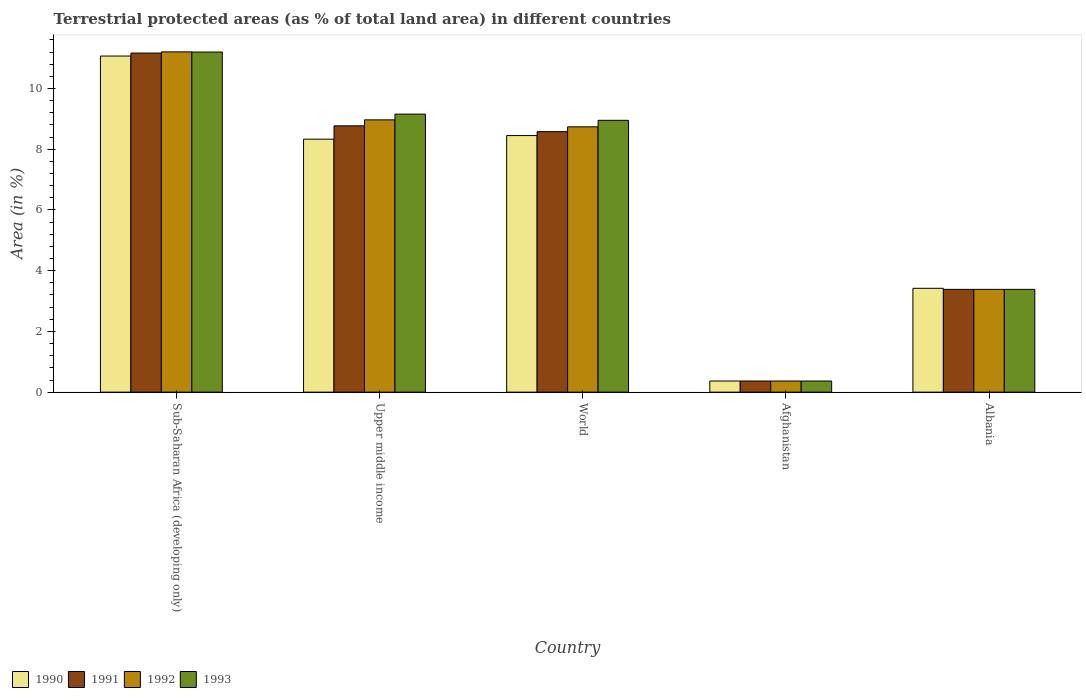How many groups of bars are there?
Your answer should be compact. 5. Are the number of bars per tick equal to the number of legend labels?
Give a very brief answer. Yes. Are the number of bars on each tick of the X-axis equal?
Your answer should be compact. Yes. How many bars are there on the 5th tick from the right?
Provide a short and direct response. 4. What is the label of the 5th group of bars from the left?
Keep it short and to the point. Albania. What is the percentage of terrestrial protected land in 1992 in Sub-Saharan Africa (developing only)?
Make the answer very short. 11.21. Across all countries, what is the maximum percentage of terrestrial protected land in 1990?
Your answer should be very brief. 11.07. Across all countries, what is the minimum percentage of terrestrial protected land in 1991?
Offer a terse response. 0.37. In which country was the percentage of terrestrial protected land in 1990 maximum?
Keep it short and to the point. Sub-Saharan Africa (developing only). In which country was the percentage of terrestrial protected land in 1991 minimum?
Provide a short and direct response. Afghanistan. What is the total percentage of terrestrial protected land in 1990 in the graph?
Provide a succinct answer. 31.64. What is the difference between the percentage of terrestrial protected land in 1991 in Afghanistan and that in World?
Ensure brevity in your answer.  -8.21. What is the difference between the percentage of terrestrial protected land in 1992 in Upper middle income and the percentage of terrestrial protected land in 1993 in Sub-Saharan Africa (developing only)?
Offer a terse response. -2.23. What is the average percentage of terrestrial protected land in 1991 per country?
Ensure brevity in your answer.  6.45. What is the difference between the percentage of terrestrial protected land of/in 1992 and percentage of terrestrial protected land of/in 1991 in Sub-Saharan Africa (developing only)?
Your response must be concise. 0.04. In how many countries, is the percentage of terrestrial protected land in 1993 greater than 5.6 %?
Give a very brief answer. 3. What is the ratio of the percentage of terrestrial protected land in 1993 in Afghanistan to that in Upper middle income?
Provide a short and direct response. 0.04. Is the percentage of terrestrial protected land in 1992 in Afghanistan less than that in Upper middle income?
Provide a succinct answer. Yes. What is the difference between the highest and the second highest percentage of terrestrial protected land in 1993?
Provide a short and direct response. -0.2. What is the difference between the highest and the lowest percentage of terrestrial protected land in 1991?
Make the answer very short. 10.8. Is the sum of the percentage of terrestrial protected land in 1990 in Afghanistan and World greater than the maximum percentage of terrestrial protected land in 1993 across all countries?
Ensure brevity in your answer.  No. What does the 2nd bar from the left in Upper middle income represents?
Provide a succinct answer. 1991. How many bars are there?
Make the answer very short. 20. Are all the bars in the graph horizontal?
Ensure brevity in your answer.  No. What is the difference between two consecutive major ticks on the Y-axis?
Your response must be concise. 2. What is the title of the graph?
Your response must be concise. Terrestrial protected areas (as % of total land area) in different countries. Does "1992" appear as one of the legend labels in the graph?
Give a very brief answer. Yes. What is the label or title of the Y-axis?
Keep it short and to the point. Area (in %). What is the Area (in %) in 1990 in Sub-Saharan Africa (developing only)?
Give a very brief answer. 11.07. What is the Area (in %) in 1991 in Sub-Saharan Africa (developing only)?
Offer a very short reply. 11.17. What is the Area (in %) in 1992 in Sub-Saharan Africa (developing only)?
Provide a succinct answer. 11.21. What is the Area (in %) of 1993 in Sub-Saharan Africa (developing only)?
Give a very brief answer. 11.2. What is the Area (in %) in 1990 in Upper middle income?
Make the answer very short. 8.33. What is the Area (in %) of 1991 in Upper middle income?
Offer a terse response. 8.77. What is the Area (in %) in 1992 in Upper middle income?
Provide a short and direct response. 8.97. What is the Area (in %) of 1993 in Upper middle income?
Offer a very short reply. 9.16. What is the Area (in %) of 1990 in World?
Offer a terse response. 8.45. What is the Area (in %) of 1991 in World?
Give a very brief answer. 8.58. What is the Area (in %) of 1992 in World?
Ensure brevity in your answer.  8.74. What is the Area (in %) of 1993 in World?
Your answer should be very brief. 8.95. What is the Area (in %) of 1990 in Afghanistan?
Give a very brief answer. 0.37. What is the Area (in %) of 1991 in Afghanistan?
Keep it short and to the point. 0.37. What is the Area (in %) of 1992 in Afghanistan?
Offer a terse response. 0.37. What is the Area (in %) in 1993 in Afghanistan?
Keep it short and to the point. 0.37. What is the Area (in %) of 1990 in Albania?
Make the answer very short. 3.42. What is the Area (in %) of 1991 in Albania?
Make the answer very short. 3.38. What is the Area (in %) in 1992 in Albania?
Keep it short and to the point. 3.38. What is the Area (in %) in 1993 in Albania?
Keep it short and to the point. 3.38. Across all countries, what is the maximum Area (in %) of 1990?
Your response must be concise. 11.07. Across all countries, what is the maximum Area (in %) in 1991?
Provide a succinct answer. 11.17. Across all countries, what is the maximum Area (in %) in 1992?
Keep it short and to the point. 11.21. Across all countries, what is the maximum Area (in %) of 1993?
Provide a short and direct response. 11.2. Across all countries, what is the minimum Area (in %) of 1990?
Provide a short and direct response. 0.37. Across all countries, what is the minimum Area (in %) of 1991?
Offer a terse response. 0.37. Across all countries, what is the minimum Area (in %) in 1992?
Your answer should be compact. 0.37. Across all countries, what is the minimum Area (in %) in 1993?
Keep it short and to the point. 0.37. What is the total Area (in %) of 1990 in the graph?
Provide a succinct answer. 31.64. What is the total Area (in %) in 1991 in the graph?
Provide a short and direct response. 32.27. What is the total Area (in %) in 1992 in the graph?
Keep it short and to the point. 32.67. What is the total Area (in %) of 1993 in the graph?
Ensure brevity in your answer.  33.06. What is the difference between the Area (in %) in 1990 in Sub-Saharan Africa (developing only) and that in Upper middle income?
Keep it short and to the point. 2.74. What is the difference between the Area (in %) of 1991 in Sub-Saharan Africa (developing only) and that in Upper middle income?
Keep it short and to the point. 2.4. What is the difference between the Area (in %) in 1992 in Sub-Saharan Africa (developing only) and that in Upper middle income?
Provide a short and direct response. 2.24. What is the difference between the Area (in %) in 1993 in Sub-Saharan Africa (developing only) and that in Upper middle income?
Your answer should be very brief. 2.04. What is the difference between the Area (in %) in 1990 in Sub-Saharan Africa (developing only) and that in World?
Provide a succinct answer. 2.62. What is the difference between the Area (in %) of 1991 in Sub-Saharan Africa (developing only) and that in World?
Make the answer very short. 2.59. What is the difference between the Area (in %) of 1992 in Sub-Saharan Africa (developing only) and that in World?
Offer a very short reply. 2.47. What is the difference between the Area (in %) in 1993 in Sub-Saharan Africa (developing only) and that in World?
Your response must be concise. 2.25. What is the difference between the Area (in %) in 1990 in Sub-Saharan Africa (developing only) and that in Afghanistan?
Your answer should be very brief. 10.7. What is the difference between the Area (in %) of 1991 in Sub-Saharan Africa (developing only) and that in Afghanistan?
Make the answer very short. 10.8. What is the difference between the Area (in %) of 1992 in Sub-Saharan Africa (developing only) and that in Afghanistan?
Offer a terse response. 10.84. What is the difference between the Area (in %) of 1993 in Sub-Saharan Africa (developing only) and that in Afghanistan?
Offer a very short reply. 10.83. What is the difference between the Area (in %) in 1990 in Sub-Saharan Africa (developing only) and that in Albania?
Offer a terse response. 7.65. What is the difference between the Area (in %) of 1991 in Sub-Saharan Africa (developing only) and that in Albania?
Keep it short and to the point. 7.78. What is the difference between the Area (in %) of 1992 in Sub-Saharan Africa (developing only) and that in Albania?
Provide a short and direct response. 7.82. What is the difference between the Area (in %) of 1993 in Sub-Saharan Africa (developing only) and that in Albania?
Give a very brief answer. 7.82. What is the difference between the Area (in %) of 1990 in Upper middle income and that in World?
Ensure brevity in your answer.  -0.12. What is the difference between the Area (in %) in 1991 in Upper middle income and that in World?
Your response must be concise. 0.19. What is the difference between the Area (in %) of 1992 in Upper middle income and that in World?
Give a very brief answer. 0.23. What is the difference between the Area (in %) of 1993 in Upper middle income and that in World?
Your answer should be very brief. 0.2. What is the difference between the Area (in %) of 1990 in Upper middle income and that in Afghanistan?
Make the answer very short. 7.97. What is the difference between the Area (in %) of 1991 in Upper middle income and that in Afghanistan?
Make the answer very short. 8.4. What is the difference between the Area (in %) in 1992 in Upper middle income and that in Afghanistan?
Provide a short and direct response. 8.6. What is the difference between the Area (in %) of 1993 in Upper middle income and that in Afghanistan?
Your answer should be very brief. 8.79. What is the difference between the Area (in %) of 1990 in Upper middle income and that in Albania?
Provide a succinct answer. 4.91. What is the difference between the Area (in %) of 1991 in Upper middle income and that in Albania?
Your response must be concise. 5.39. What is the difference between the Area (in %) of 1992 in Upper middle income and that in Albania?
Offer a terse response. 5.58. What is the difference between the Area (in %) of 1993 in Upper middle income and that in Albania?
Your answer should be very brief. 5.77. What is the difference between the Area (in %) of 1990 in World and that in Afghanistan?
Provide a succinct answer. 8.08. What is the difference between the Area (in %) of 1991 in World and that in Afghanistan?
Your response must be concise. 8.21. What is the difference between the Area (in %) in 1992 in World and that in Afghanistan?
Your response must be concise. 8.37. What is the difference between the Area (in %) in 1993 in World and that in Afghanistan?
Your answer should be very brief. 8.59. What is the difference between the Area (in %) of 1990 in World and that in Albania?
Provide a succinct answer. 5.03. What is the difference between the Area (in %) in 1991 in World and that in Albania?
Keep it short and to the point. 5.2. What is the difference between the Area (in %) of 1992 in World and that in Albania?
Provide a succinct answer. 5.35. What is the difference between the Area (in %) of 1993 in World and that in Albania?
Provide a short and direct response. 5.57. What is the difference between the Area (in %) in 1990 in Afghanistan and that in Albania?
Your response must be concise. -3.05. What is the difference between the Area (in %) in 1991 in Afghanistan and that in Albania?
Ensure brevity in your answer.  -3.02. What is the difference between the Area (in %) in 1992 in Afghanistan and that in Albania?
Keep it short and to the point. -3.02. What is the difference between the Area (in %) of 1993 in Afghanistan and that in Albania?
Offer a terse response. -3.02. What is the difference between the Area (in %) in 1990 in Sub-Saharan Africa (developing only) and the Area (in %) in 1991 in Upper middle income?
Ensure brevity in your answer.  2.3. What is the difference between the Area (in %) in 1990 in Sub-Saharan Africa (developing only) and the Area (in %) in 1992 in Upper middle income?
Offer a terse response. 2.1. What is the difference between the Area (in %) in 1990 in Sub-Saharan Africa (developing only) and the Area (in %) in 1993 in Upper middle income?
Offer a very short reply. 1.91. What is the difference between the Area (in %) in 1991 in Sub-Saharan Africa (developing only) and the Area (in %) in 1992 in Upper middle income?
Make the answer very short. 2.2. What is the difference between the Area (in %) in 1991 in Sub-Saharan Africa (developing only) and the Area (in %) in 1993 in Upper middle income?
Your response must be concise. 2.01. What is the difference between the Area (in %) in 1992 in Sub-Saharan Africa (developing only) and the Area (in %) in 1993 in Upper middle income?
Provide a succinct answer. 2.05. What is the difference between the Area (in %) in 1990 in Sub-Saharan Africa (developing only) and the Area (in %) in 1991 in World?
Your answer should be compact. 2.49. What is the difference between the Area (in %) in 1990 in Sub-Saharan Africa (developing only) and the Area (in %) in 1992 in World?
Ensure brevity in your answer.  2.33. What is the difference between the Area (in %) in 1990 in Sub-Saharan Africa (developing only) and the Area (in %) in 1993 in World?
Ensure brevity in your answer.  2.12. What is the difference between the Area (in %) in 1991 in Sub-Saharan Africa (developing only) and the Area (in %) in 1992 in World?
Your answer should be compact. 2.43. What is the difference between the Area (in %) of 1991 in Sub-Saharan Africa (developing only) and the Area (in %) of 1993 in World?
Provide a succinct answer. 2.22. What is the difference between the Area (in %) of 1992 in Sub-Saharan Africa (developing only) and the Area (in %) of 1993 in World?
Your answer should be compact. 2.25. What is the difference between the Area (in %) of 1990 in Sub-Saharan Africa (developing only) and the Area (in %) of 1991 in Afghanistan?
Offer a terse response. 10.7. What is the difference between the Area (in %) of 1990 in Sub-Saharan Africa (developing only) and the Area (in %) of 1992 in Afghanistan?
Provide a short and direct response. 10.7. What is the difference between the Area (in %) of 1990 in Sub-Saharan Africa (developing only) and the Area (in %) of 1993 in Afghanistan?
Your answer should be very brief. 10.7. What is the difference between the Area (in %) in 1991 in Sub-Saharan Africa (developing only) and the Area (in %) in 1992 in Afghanistan?
Your response must be concise. 10.8. What is the difference between the Area (in %) of 1991 in Sub-Saharan Africa (developing only) and the Area (in %) of 1993 in Afghanistan?
Give a very brief answer. 10.8. What is the difference between the Area (in %) in 1992 in Sub-Saharan Africa (developing only) and the Area (in %) in 1993 in Afghanistan?
Ensure brevity in your answer.  10.84. What is the difference between the Area (in %) of 1990 in Sub-Saharan Africa (developing only) and the Area (in %) of 1991 in Albania?
Ensure brevity in your answer.  7.68. What is the difference between the Area (in %) in 1990 in Sub-Saharan Africa (developing only) and the Area (in %) in 1992 in Albania?
Provide a succinct answer. 7.68. What is the difference between the Area (in %) in 1990 in Sub-Saharan Africa (developing only) and the Area (in %) in 1993 in Albania?
Offer a terse response. 7.68. What is the difference between the Area (in %) in 1991 in Sub-Saharan Africa (developing only) and the Area (in %) in 1992 in Albania?
Give a very brief answer. 7.78. What is the difference between the Area (in %) of 1991 in Sub-Saharan Africa (developing only) and the Area (in %) of 1993 in Albania?
Make the answer very short. 7.78. What is the difference between the Area (in %) in 1992 in Sub-Saharan Africa (developing only) and the Area (in %) in 1993 in Albania?
Make the answer very short. 7.82. What is the difference between the Area (in %) of 1990 in Upper middle income and the Area (in %) of 1991 in World?
Provide a short and direct response. -0.25. What is the difference between the Area (in %) of 1990 in Upper middle income and the Area (in %) of 1992 in World?
Keep it short and to the point. -0.41. What is the difference between the Area (in %) in 1990 in Upper middle income and the Area (in %) in 1993 in World?
Ensure brevity in your answer.  -0.62. What is the difference between the Area (in %) of 1991 in Upper middle income and the Area (in %) of 1992 in World?
Provide a short and direct response. 0.03. What is the difference between the Area (in %) in 1991 in Upper middle income and the Area (in %) in 1993 in World?
Your response must be concise. -0.18. What is the difference between the Area (in %) in 1992 in Upper middle income and the Area (in %) in 1993 in World?
Ensure brevity in your answer.  0.02. What is the difference between the Area (in %) in 1990 in Upper middle income and the Area (in %) in 1991 in Afghanistan?
Give a very brief answer. 7.97. What is the difference between the Area (in %) of 1990 in Upper middle income and the Area (in %) of 1992 in Afghanistan?
Ensure brevity in your answer.  7.97. What is the difference between the Area (in %) in 1990 in Upper middle income and the Area (in %) in 1993 in Afghanistan?
Your answer should be compact. 7.97. What is the difference between the Area (in %) of 1991 in Upper middle income and the Area (in %) of 1992 in Afghanistan?
Your answer should be very brief. 8.4. What is the difference between the Area (in %) of 1991 in Upper middle income and the Area (in %) of 1993 in Afghanistan?
Offer a terse response. 8.4. What is the difference between the Area (in %) in 1992 in Upper middle income and the Area (in %) in 1993 in Afghanistan?
Make the answer very short. 8.6. What is the difference between the Area (in %) of 1990 in Upper middle income and the Area (in %) of 1991 in Albania?
Your answer should be compact. 4.95. What is the difference between the Area (in %) in 1990 in Upper middle income and the Area (in %) in 1992 in Albania?
Offer a very short reply. 4.95. What is the difference between the Area (in %) of 1990 in Upper middle income and the Area (in %) of 1993 in Albania?
Make the answer very short. 4.95. What is the difference between the Area (in %) in 1991 in Upper middle income and the Area (in %) in 1992 in Albania?
Your answer should be very brief. 5.39. What is the difference between the Area (in %) of 1991 in Upper middle income and the Area (in %) of 1993 in Albania?
Give a very brief answer. 5.39. What is the difference between the Area (in %) of 1992 in Upper middle income and the Area (in %) of 1993 in Albania?
Your answer should be compact. 5.58. What is the difference between the Area (in %) in 1990 in World and the Area (in %) in 1991 in Afghanistan?
Ensure brevity in your answer.  8.08. What is the difference between the Area (in %) of 1990 in World and the Area (in %) of 1992 in Afghanistan?
Keep it short and to the point. 8.08. What is the difference between the Area (in %) of 1990 in World and the Area (in %) of 1993 in Afghanistan?
Make the answer very short. 8.08. What is the difference between the Area (in %) in 1991 in World and the Area (in %) in 1992 in Afghanistan?
Your answer should be very brief. 8.21. What is the difference between the Area (in %) of 1991 in World and the Area (in %) of 1993 in Afghanistan?
Your response must be concise. 8.21. What is the difference between the Area (in %) of 1992 in World and the Area (in %) of 1993 in Afghanistan?
Make the answer very short. 8.37. What is the difference between the Area (in %) of 1990 in World and the Area (in %) of 1991 in Albania?
Your answer should be compact. 5.07. What is the difference between the Area (in %) of 1990 in World and the Area (in %) of 1992 in Albania?
Your answer should be compact. 5.07. What is the difference between the Area (in %) of 1990 in World and the Area (in %) of 1993 in Albania?
Provide a short and direct response. 5.07. What is the difference between the Area (in %) of 1991 in World and the Area (in %) of 1992 in Albania?
Your answer should be compact. 5.2. What is the difference between the Area (in %) of 1991 in World and the Area (in %) of 1993 in Albania?
Your response must be concise. 5.2. What is the difference between the Area (in %) in 1992 in World and the Area (in %) in 1993 in Albania?
Give a very brief answer. 5.35. What is the difference between the Area (in %) of 1990 in Afghanistan and the Area (in %) of 1991 in Albania?
Your response must be concise. -3.02. What is the difference between the Area (in %) of 1990 in Afghanistan and the Area (in %) of 1992 in Albania?
Ensure brevity in your answer.  -3.02. What is the difference between the Area (in %) in 1990 in Afghanistan and the Area (in %) in 1993 in Albania?
Your response must be concise. -3.02. What is the difference between the Area (in %) of 1991 in Afghanistan and the Area (in %) of 1992 in Albania?
Your response must be concise. -3.02. What is the difference between the Area (in %) of 1991 in Afghanistan and the Area (in %) of 1993 in Albania?
Make the answer very short. -3.02. What is the difference between the Area (in %) in 1992 in Afghanistan and the Area (in %) in 1993 in Albania?
Your answer should be compact. -3.02. What is the average Area (in %) of 1990 per country?
Your response must be concise. 6.33. What is the average Area (in %) of 1991 per country?
Provide a short and direct response. 6.45. What is the average Area (in %) of 1992 per country?
Keep it short and to the point. 6.53. What is the average Area (in %) of 1993 per country?
Provide a succinct answer. 6.61. What is the difference between the Area (in %) of 1990 and Area (in %) of 1991 in Sub-Saharan Africa (developing only)?
Keep it short and to the point. -0.1. What is the difference between the Area (in %) of 1990 and Area (in %) of 1992 in Sub-Saharan Africa (developing only)?
Give a very brief answer. -0.14. What is the difference between the Area (in %) of 1990 and Area (in %) of 1993 in Sub-Saharan Africa (developing only)?
Provide a short and direct response. -0.13. What is the difference between the Area (in %) of 1991 and Area (in %) of 1992 in Sub-Saharan Africa (developing only)?
Make the answer very short. -0.04. What is the difference between the Area (in %) in 1991 and Area (in %) in 1993 in Sub-Saharan Africa (developing only)?
Offer a terse response. -0.03. What is the difference between the Area (in %) in 1992 and Area (in %) in 1993 in Sub-Saharan Africa (developing only)?
Your answer should be very brief. 0. What is the difference between the Area (in %) of 1990 and Area (in %) of 1991 in Upper middle income?
Provide a short and direct response. -0.44. What is the difference between the Area (in %) of 1990 and Area (in %) of 1992 in Upper middle income?
Your answer should be compact. -0.64. What is the difference between the Area (in %) in 1990 and Area (in %) in 1993 in Upper middle income?
Make the answer very short. -0.83. What is the difference between the Area (in %) of 1991 and Area (in %) of 1992 in Upper middle income?
Ensure brevity in your answer.  -0.2. What is the difference between the Area (in %) in 1991 and Area (in %) in 1993 in Upper middle income?
Offer a very short reply. -0.39. What is the difference between the Area (in %) in 1992 and Area (in %) in 1993 in Upper middle income?
Keep it short and to the point. -0.19. What is the difference between the Area (in %) of 1990 and Area (in %) of 1991 in World?
Your answer should be compact. -0.13. What is the difference between the Area (in %) in 1990 and Area (in %) in 1992 in World?
Make the answer very short. -0.29. What is the difference between the Area (in %) in 1990 and Area (in %) in 1993 in World?
Keep it short and to the point. -0.5. What is the difference between the Area (in %) of 1991 and Area (in %) of 1992 in World?
Your answer should be compact. -0.16. What is the difference between the Area (in %) in 1991 and Area (in %) in 1993 in World?
Ensure brevity in your answer.  -0.37. What is the difference between the Area (in %) in 1992 and Area (in %) in 1993 in World?
Offer a very short reply. -0.21. What is the difference between the Area (in %) in 1990 and Area (in %) in 1992 in Afghanistan?
Your response must be concise. 0. What is the difference between the Area (in %) of 1990 and Area (in %) of 1993 in Afghanistan?
Your answer should be very brief. 0. What is the difference between the Area (in %) in 1991 and Area (in %) in 1993 in Afghanistan?
Offer a very short reply. 0. What is the difference between the Area (in %) in 1992 and Area (in %) in 1993 in Afghanistan?
Keep it short and to the point. 0. What is the difference between the Area (in %) of 1990 and Area (in %) of 1991 in Albania?
Offer a terse response. 0.04. What is the difference between the Area (in %) in 1990 and Area (in %) in 1992 in Albania?
Your answer should be very brief. 0.04. What is the difference between the Area (in %) in 1990 and Area (in %) in 1993 in Albania?
Your answer should be compact. 0.04. What is the ratio of the Area (in %) in 1990 in Sub-Saharan Africa (developing only) to that in Upper middle income?
Your answer should be compact. 1.33. What is the ratio of the Area (in %) of 1991 in Sub-Saharan Africa (developing only) to that in Upper middle income?
Your response must be concise. 1.27. What is the ratio of the Area (in %) of 1992 in Sub-Saharan Africa (developing only) to that in Upper middle income?
Make the answer very short. 1.25. What is the ratio of the Area (in %) in 1993 in Sub-Saharan Africa (developing only) to that in Upper middle income?
Offer a very short reply. 1.22. What is the ratio of the Area (in %) of 1990 in Sub-Saharan Africa (developing only) to that in World?
Your response must be concise. 1.31. What is the ratio of the Area (in %) in 1991 in Sub-Saharan Africa (developing only) to that in World?
Keep it short and to the point. 1.3. What is the ratio of the Area (in %) in 1992 in Sub-Saharan Africa (developing only) to that in World?
Provide a short and direct response. 1.28. What is the ratio of the Area (in %) in 1993 in Sub-Saharan Africa (developing only) to that in World?
Ensure brevity in your answer.  1.25. What is the ratio of the Area (in %) of 1990 in Sub-Saharan Africa (developing only) to that in Afghanistan?
Your response must be concise. 30.17. What is the ratio of the Area (in %) in 1991 in Sub-Saharan Africa (developing only) to that in Afghanistan?
Give a very brief answer. 30.44. What is the ratio of the Area (in %) of 1992 in Sub-Saharan Africa (developing only) to that in Afghanistan?
Ensure brevity in your answer.  30.55. What is the ratio of the Area (in %) of 1993 in Sub-Saharan Africa (developing only) to that in Afghanistan?
Provide a short and direct response. 30.53. What is the ratio of the Area (in %) in 1990 in Sub-Saharan Africa (developing only) to that in Albania?
Make the answer very short. 3.24. What is the ratio of the Area (in %) in 1991 in Sub-Saharan Africa (developing only) to that in Albania?
Give a very brief answer. 3.3. What is the ratio of the Area (in %) of 1992 in Sub-Saharan Africa (developing only) to that in Albania?
Give a very brief answer. 3.31. What is the ratio of the Area (in %) in 1993 in Sub-Saharan Africa (developing only) to that in Albania?
Provide a succinct answer. 3.31. What is the ratio of the Area (in %) in 1990 in Upper middle income to that in World?
Offer a very short reply. 0.99. What is the ratio of the Area (in %) of 1991 in Upper middle income to that in World?
Offer a very short reply. 1.02. What is the ratio of the Area (in %) in 1992 in Upper middle income to that in World?
Keep it short and to the point. 1.03. What is the ratio of the Area (in %) in 1993 in Upper middle income to that in World?
Make the answer very short. 1.02. What is the ratio of the Area (in %) in 1990 in Upper middle income to that in Afghanistan?
Keep it short and to the point. 22.71. What is the ratio of the Area (in %) in 1991 in Upper middle income to that in Afghanistan?
Give a very brief answer. 23.91. What is the ratio of the Area (in %) of 1992 in Upper middle income to that in Afghanistan?
Keep it short and to the point. 24.44. What is the ratio of the Area (in %) of 1993 in Upper middle income to that in Afghanistan?
Your response must be concise. 24.96. What is the ratio of the Area (in %) in 1990 in Upper middle income to that in Albania?
Your answer should be compact. 2.44. What is the ratio of the Area (in %) in 1991 in Upper middle income to that in Albania?
Ensure brevity in your answer.  2.59. What is the ratio of the Area (in %) of 1992 in Upper middle income to that in Albania?
Your answer should be very brief. 2.65. What is the ratio of the Area (in %) in 1993 in Upper middle income to that in Albania?
Provide a short and direct response. 2.71. What is the ratio of the Area (in %) in 1990 in World to that in Afghanistan?
Provide a short and direct response. 23.03. What is the ratio of the Area (in %) of 1991 in World to that in Afghanistan?
Your answer should be compact. 23.39. What is the ratio of the Area (in %) of 1992 in World to that in Afghanistan?
Provide a short and direct response. 23.82. What is the ratio of the Area (in %) of 1993 in World to that in Afghanistan?
Give a very brief answer. 24.4. What is the ratio of the Area (in %) of 1990 in World to that in Albania?
Your answer should be very brief. 2.47. What is the ratio of the Area (in %) of 1991 in World to that in Albania?
Make the answer very short. 2.53. What is the ratio of the Area (in %) in 1992 in World to that in Albania?
Provide a succinct answer. 2.58. What is the ratio of the Area (in %) of 1993 in World to that in Albania?
Make the answer very short. 2.64. What is the ratio of the Area (in %) of 1990 in Afghanistan to that in Albania?
Your answer should be compact. 0.11. What is the ratio of the Area (in %) of 1991 in Afghanistan to that in Albania?
Offer a very short reply. 0.11. What is the ratio of the Area (in %) in 1992 in Afghanistan to that in Albania?
Make the answer very short. 0.11. What is the ratio of the Area (in %) in 1993 in Afghanistan to that in Albania?
Your response must be concise. 0.11. What is the difference between the highest and the second highest Area (in %) of 1990?
Make the answer very short. 2.62. What is the difference between the highest and the second highest Area (in %) in 1991?
Give a very brief answer. 2.4. What is the difference between the highest and the second highest Area (in %) of 1992?
Provide a short and direct response. 2.24. What is the difference between the highest and the second highest Area (in %) of 1993?
Make the answer very short. 2.04. What is the difference between the highest and the lowest Area (in %) in 1990?
Offer a terse response. 10.7. What is the difference between the highest and the lowest Area (in %) of 1991?
Ensure brevity in your answer.  10.8. What is the difference between the highest and the lowest Area (in %) of 1992?
Your answer should be very brief. 10.84. What is the difference between the highest and the lowest Area (in %) in 1993?
Provide a succinct answer. 10.83. 